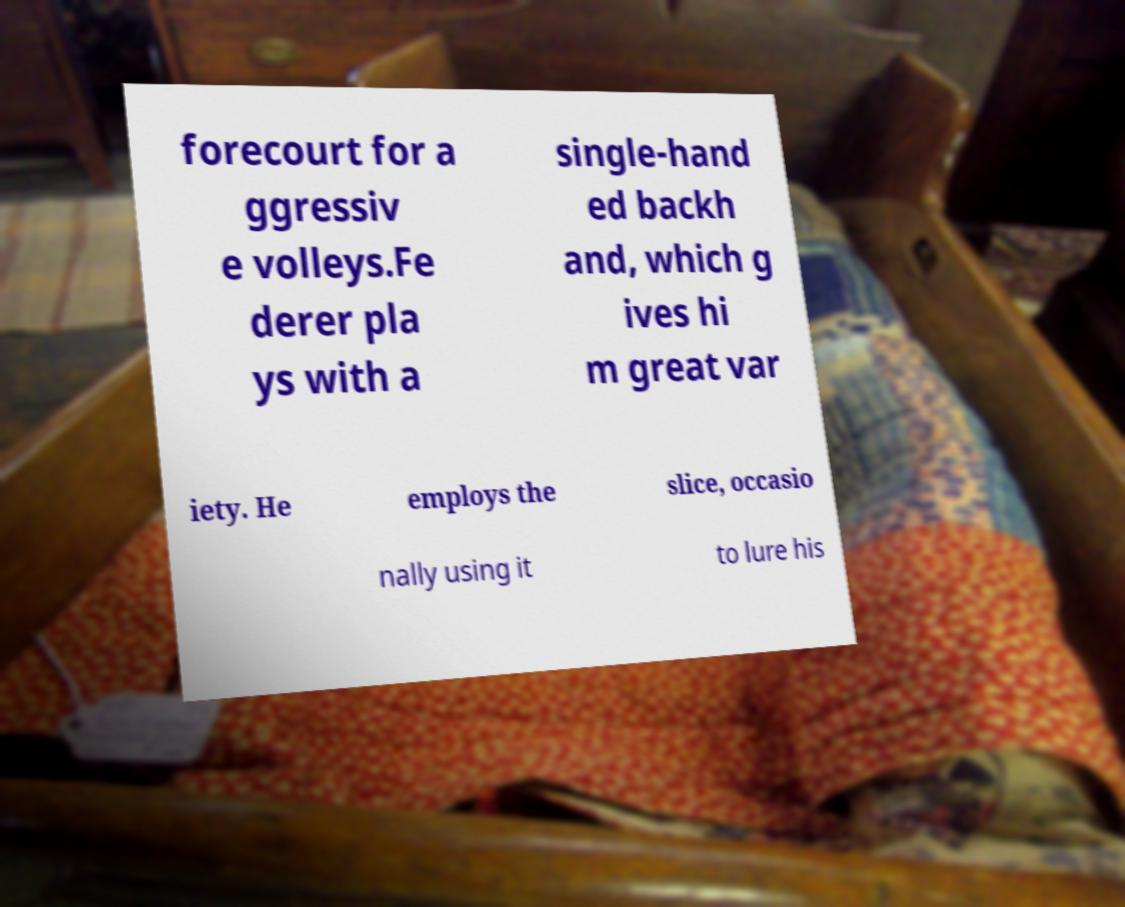Can you accurately transcribe the text from the provided image for me? forecourt for a ggressiv e volleys.Fe derer pla ys with a single-hand ed backh and, which g ives hi m great var iety. He employs the slice, occasio nally using it to lure his 